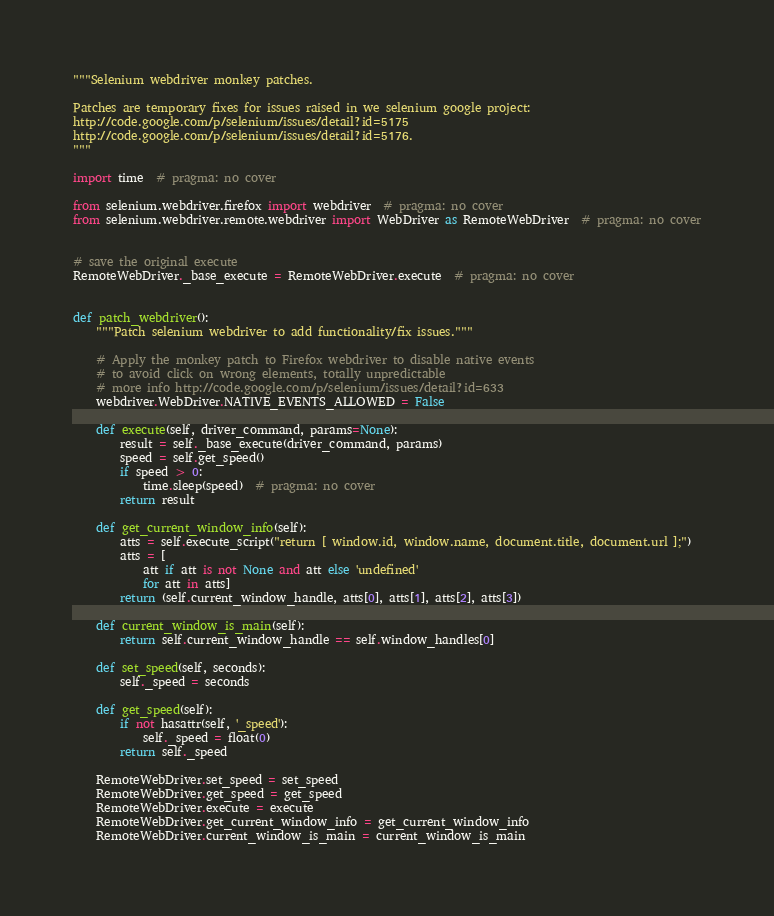Convert code to text. <code><loc_0><loc_0><loc_500><loc_500><_Python_>"""Selenium webdriver monkey patches.

Patches are temporary fixes for issues raised in we selenium google project:
http://code.google.com/p/selenium/issues/detail?id=5175
http://code.google.com/p/selenium/issues/detail?id=5176.
"""

import time  # pragma: no cover

from selenium.webdriver.firefox import webdriver  # pragma: no cover
from selenium.webdriver.remote.webdriver import WebDriver as RemoteWebDriver  # pragma: no cover


# save the original execute
RemoteWebDriver._base_execute = RemoteWebDriver.execute  # pragma: no cover


def patch_webdriver():
    """Patch selenium webdriver to add functionality/fix issues."""

    # Apply the monkey patch to Firefox webdriver to disable native events
    # to avoid click on wrong elements, totally unpredictable
    # more info http://code.google.com/p/selenium/issues/detail?id=633
    webdriver.WebDriver.NATIVE_EVENTS_ALLOWED = False

    def execute(self, driver_command, params=None):
        result = self._base_execute(driver_command, params)
        speed = self.get_speed()
        if speed > 0:
            time.sleep(speed)  # pragma: no cover
        return result

    def get_current_window_info(self):
        atts = self.execute_script("return [ window.id, window.name, document.title, document.url ];")
        atts = [
            att if att is not None and att else 'undefined'
            for att in atts]
        return (self.current_window_handle, atts[0], atts[1], atts[2], atts[3])

    def current_window_is_main(self):
        return self.current_window_handle == self.window_handles[0]

    def set_speed(self, seconds):
        self._speed = seconds

    def get_speed(self):
        if not hasattr(self, '_speed'):
            self._speed = float(0)
        return self._speed

    RemoteWebDriver.set_speed = set_speed
    RemoteWebDriver.get_speed = get_speed
    RemoteWebDriver.execute = execute
    RemoteWebDriver.get_current_window_info = get_current_window_info
    RemoteWebDriver.current_window_is_main = current_window_is_main
</code> 